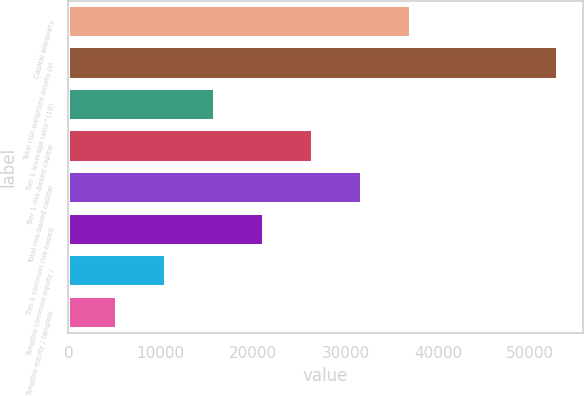Convert chart to OTSL. <chart><loc_0><loc_0><loc_500><loc_500><bar_chart><fcel>Capital adequacy<fcel>Total risk-weighted assets (in<fcel>Tier 1 leverage ratio^(10)<fcel>Tier 1 risk-based capital<fcel>Total risk-based capital<fcel>Tier 1 common risk-based<fcel>Tangible common equity /<fcel>Tangible equity / tangible<nl><fcel>37127<fcel>53035<fcel>15916.4<fcel>26521.7<fcel>31824.3<fcel>21219<fcel>10613.7<fcel>5311.04<nl></chart> 